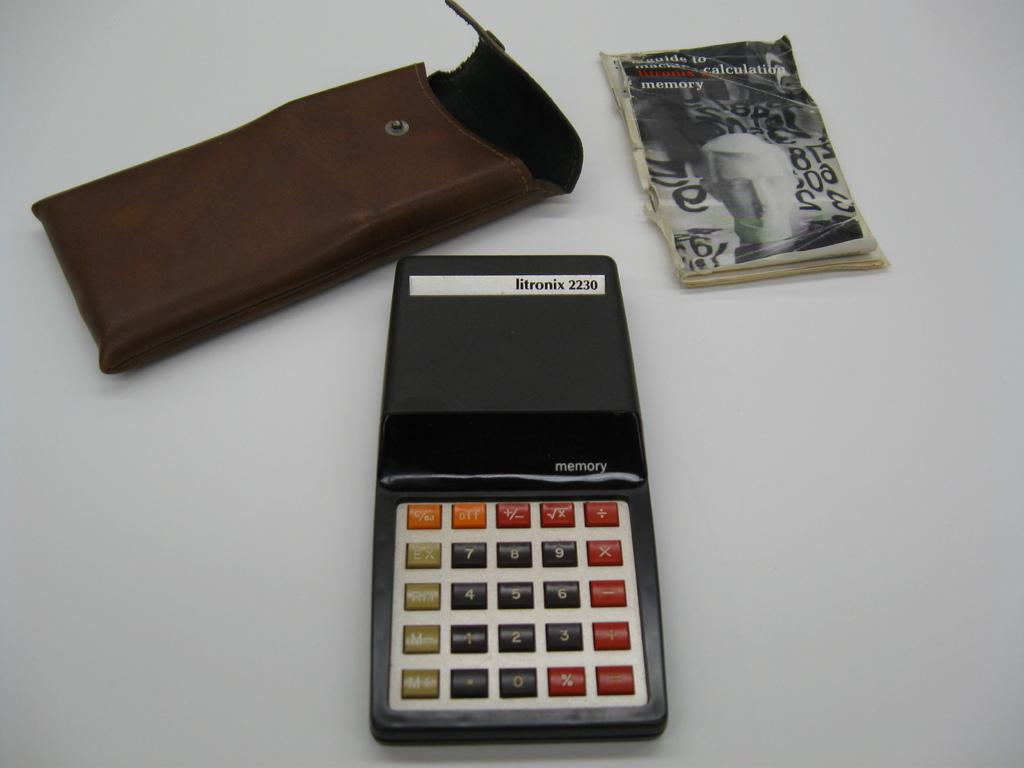<image>
Offer a succinct explanation of the picture presented. An old litronix calculator with its case and manual. 